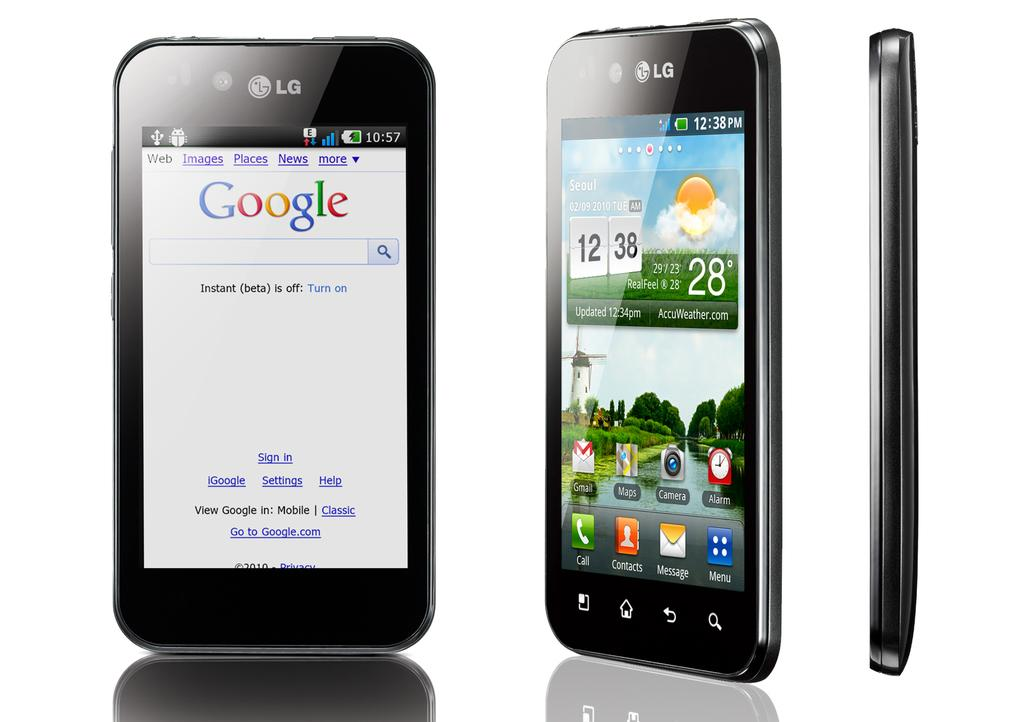<image>
Describe the image concisely. a phone with 28 degrees written on it 